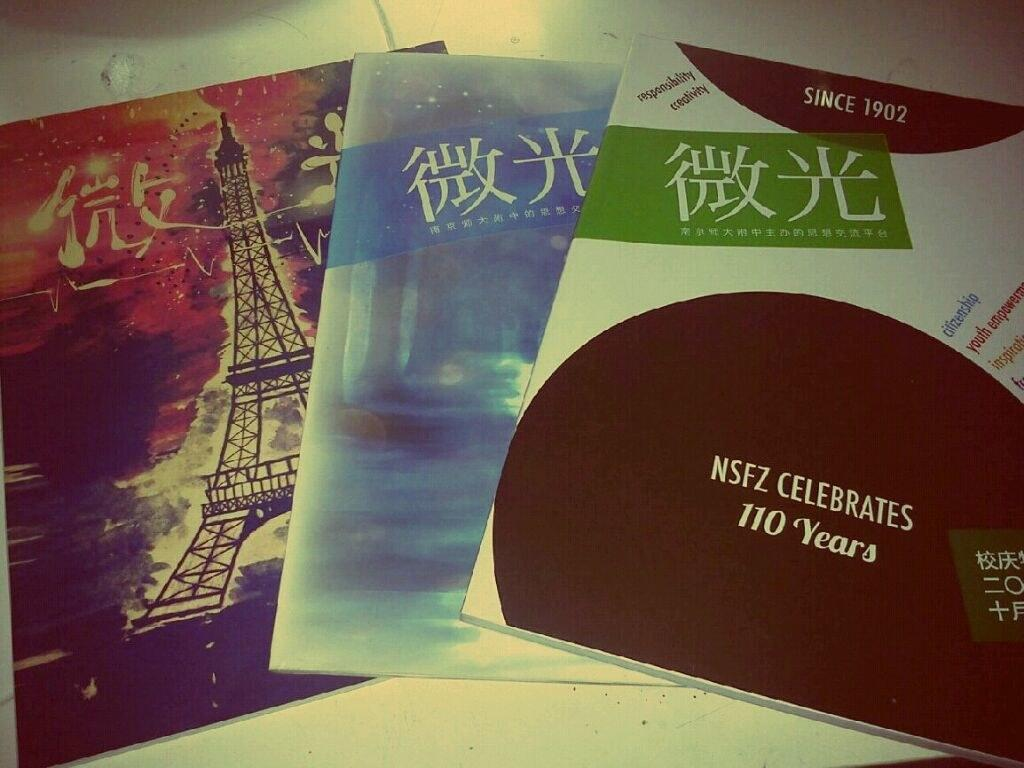<image>
Create a compact narrative representing the image presented. A stack of flyers from NSFZ  sits on a table. 